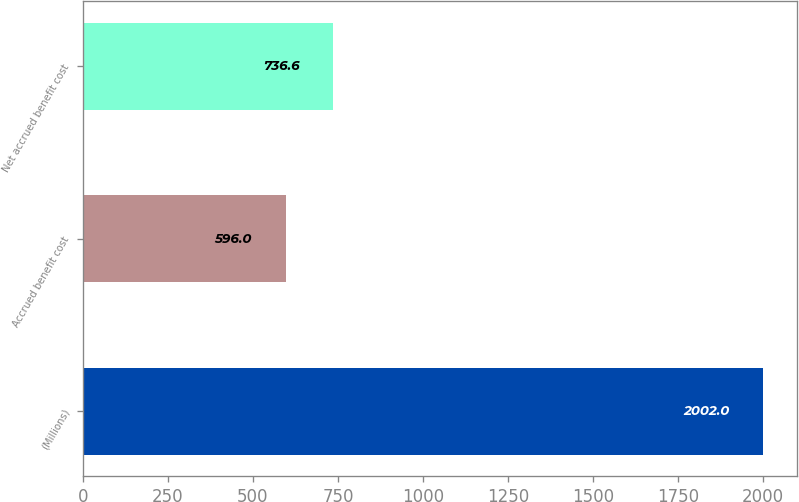Convert chart. <chart><loc_0><loc_0><loc_500><loc_500><bar_chart><fcel>(Millions)<fcel>Accrued benefit cost<fcel>Net accrued benefit cost<nl><fcel>2002<fcel>596<fcel>736.6<nl></chart> 